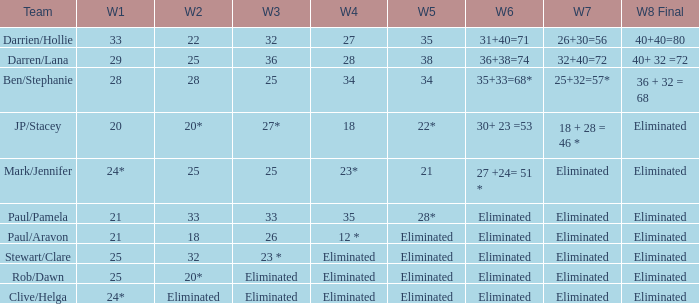Name the week 3 of 36 29.0. Give me the full table as a dictionary. {'header': ['Team', 'W1', 'W2', 'W3', 'W4', 'W5', 'W6', 'W7', 'W8 Final'], 'rows': [['Darrien/Hollie', '33', '22', '32', '27', '35', '31+40=71', '26+30=56', '40+40=80'], ['Darren/Lana', '29', '25', '36', '28', '38', '36+38=74', '32+40=72', '40+ 32 =72'], ['Ben/Stephanie', '28', '28', '25', '34', '34', '35+33=68*', '25+32=57*', '36 + 32 = 68'], ['JP/Stacey', '20', '20*', '27*', '18', '22*', '30+ 23 =53', '18 + 28 = 46 *', 'Eliminated'], ['Mark/Jennifer', '24*', '25', '25', '23*', '21', '27 +24= 51 *', 'Eliminated', 'Eliminated'], ['Paul/Pamela', '21', '33', '33', '35', '28*', 'Eliminated', 'Eliminated', 'Eliminated'], ['Paul/Aravon', '21', '18', '26', '12 *', 'Eliminated', 'Eliminated', 'Eliminated', 'Eliminated'], ['Stewart/Clare', '25', '32', '23 *', 'Eliminated', 'Eliminated', 'Eliminated', 'Eliminated', 'Eliminated'], ['Rob/Dawn', '25', '20*', 'Eliminated', 'Eliminated', 'Eliminated', 'Eliminated', 'Eliminated', 'Eliminated'], ['Clive/Helga', '24*', 'Eliminated', 'Eliminated', 'Eliminated', 'Eliminated', 'Eliminated', 'Eliminated', 'Eliminated']]} 